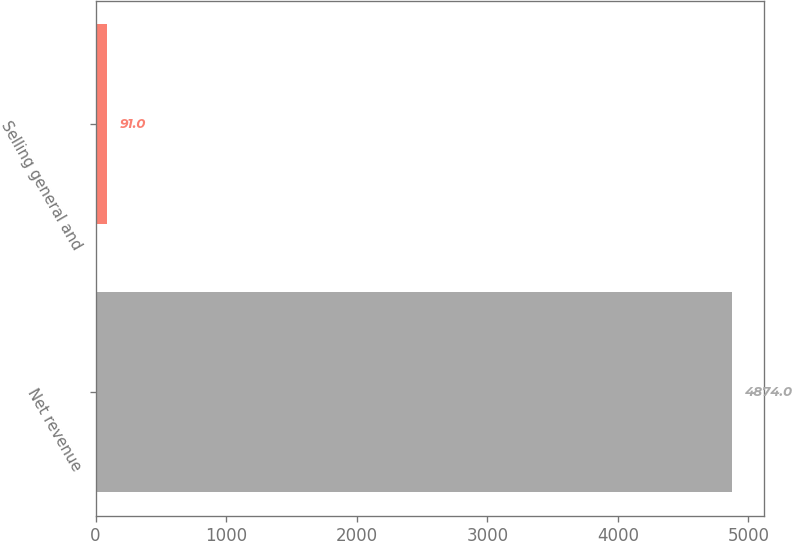Convert chart. <chart><loc_0><loc_0><loc_500><loc_500><bar_chart><fcel>Net revenue<fcel>Selling general and<nl><fcel>4874<fcel>91<nl></chart> 